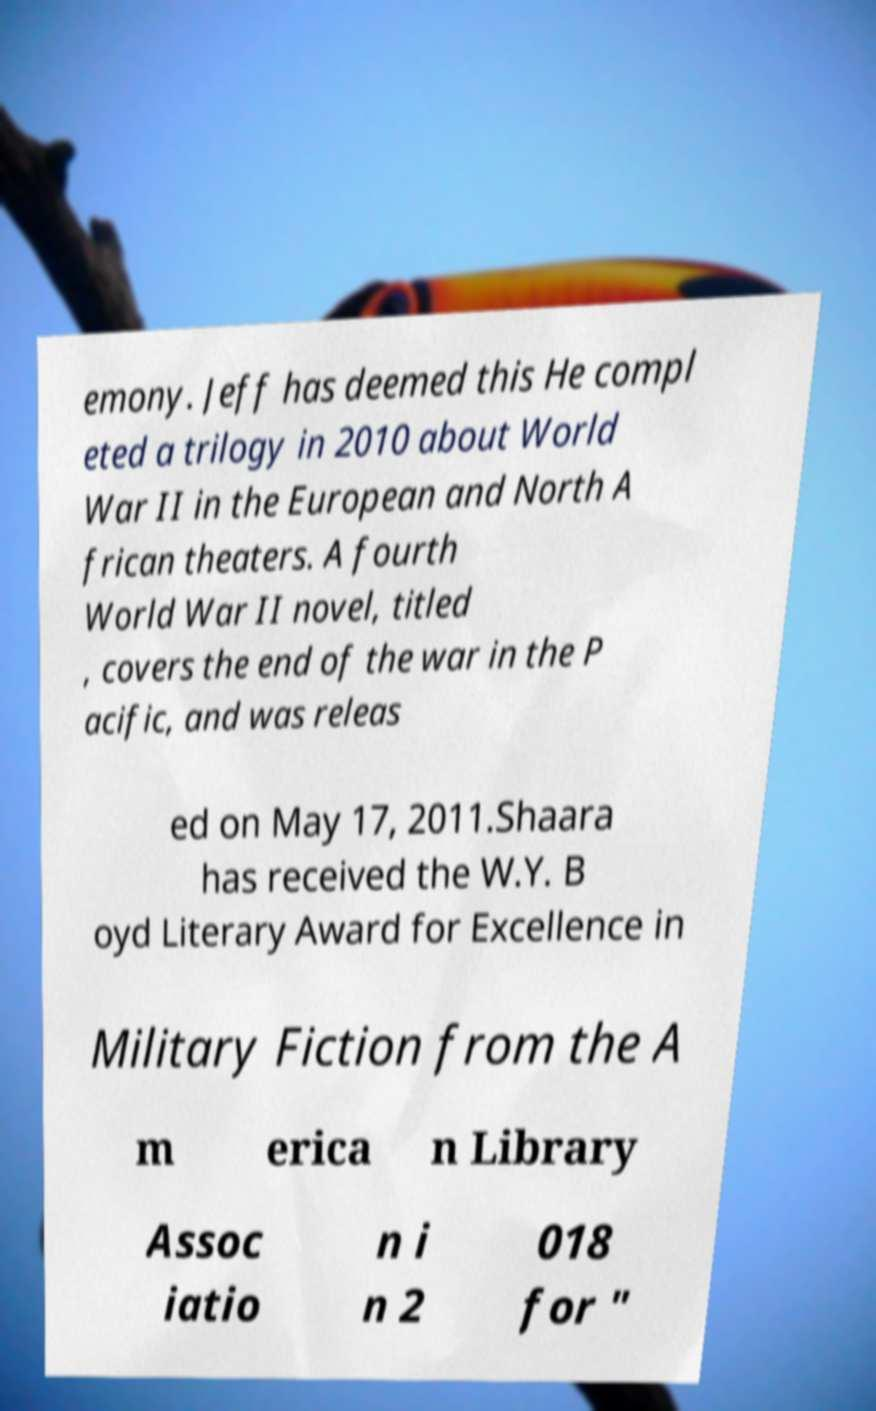I need the written content from this picture converted into text. Can you do that? emony. Jeff has deemed this He compl eted a trilogy in 2010 about World War II in the European and North A frican theaters. A fourth World War II novel, titled , covers the end of the war in the P acific, and was releas ed on May 17, 2011.Shaara has received the W.Y. B oyd Literary Award for Excellence in Military Fiction from the A m erica n Library Assoc iatio n i n 2 018 for " 